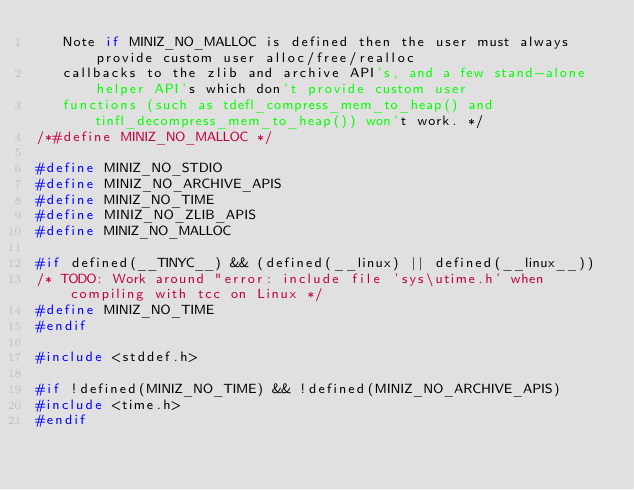Convert code to text. <code><loc_0><loc_0><loc_500><loc_500><_C_>   Note if MINIZ_NO_MALLOC is defined then the user must always provide custom user alloc/free/realloc
   callbacks to the zlib and archive API's, and a few stand-alone helper API's which don't provide custom user
   functions (such as tdefl_compress_mem_to_heap() and tinfl_decompress_mem_to_heap()) won't work. */
/*#define MINIZ_NO_MALLOC */

#define MINIZ_NO_STDIO
#define MINIZ_NO_ARCHIVE_APIS
#define MINIZ_NO_TIME
#define MINIZ_NO_ZLIB_APIS
#define MINIZ_NO_MALLOC

#if defined(__TINYC__) && (defined(__linux) || defined(__linux__))
/* TODO: Work around "error: include file 'sys\utime.h' when compiling with tcc on Linux */
#define MINIZ_NO_TIME
#endif

#include <stddef.h>

#if !defined(MINIZ_NO_TIME) && !defined(MINIZ_NO_ARCHIVE_APIS)
#include <time.h>
#endif
</code> 